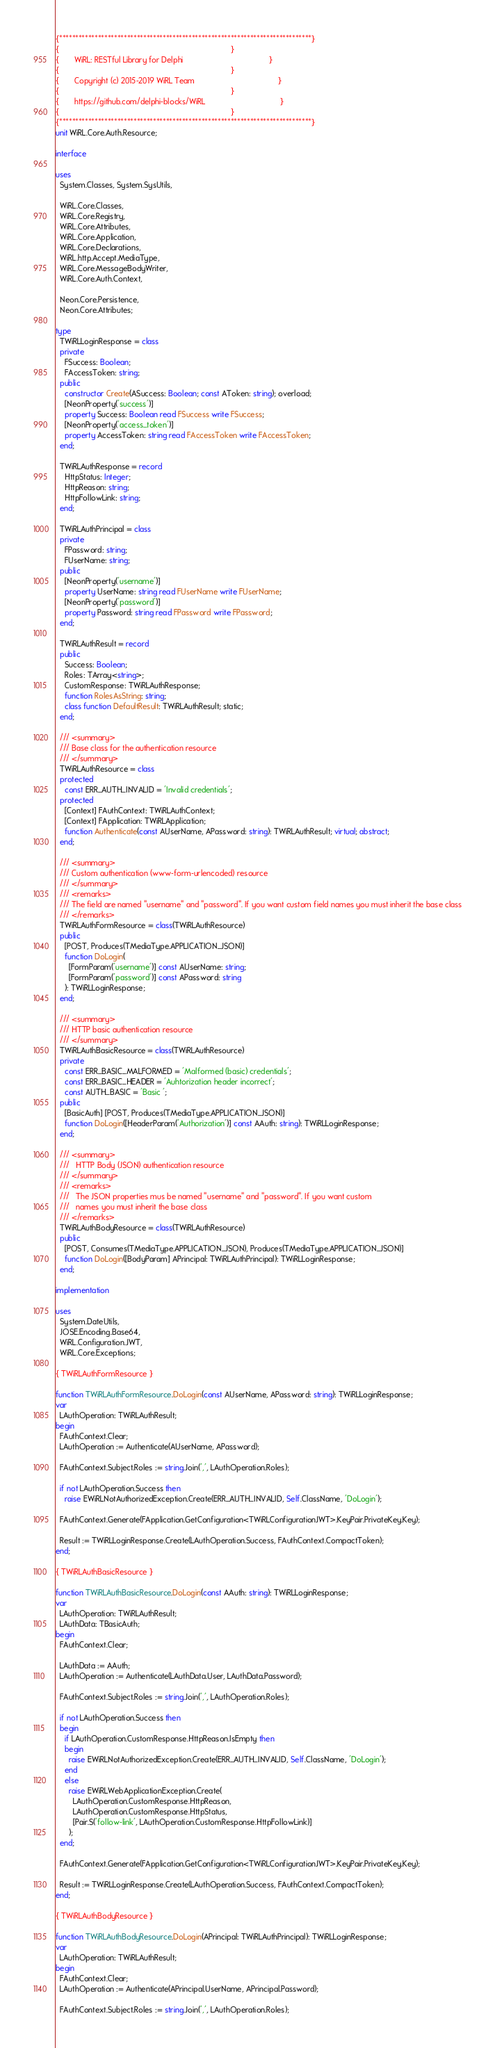<code> <loc_0><loc_0><loc_500><loc_500><_Pascal_>{******************************************************************************}
{                                                                              }
{       WiRL: RESTful Library for Delphi                                       }
{                                                                              }
{       Copyright (c) 2015-2019 WiRL Team                                      }
{                                                                              }
{       https://github.com/delphi-blocks/WiRL                                  }
{                                                                              }
{******************************************************************************}
unit WiRL.Core.Auth.Resource;

interface

uses
  System.Classes, System.SysUtils,

  WiRL.Core.Classes,
  WiRL.Core.Registry,
  WiRL.Core.Attributes,
  WiRL.Core.Application,
  WiRL.Core.Declarations,
  WiRL.http.Accept.MediaType,
  WiRL.Core.MessageBodyWriter,
  WiRL.Core.Auth.Context,

  Neon.Core.Persistence,
  Neon.Core.Attributes;

type
  TWiRLLoginResponse = class
  private
    FSuccess: Boolean;
    FAccessToken: string;
  public
    constructor Create(ASuccess: Boolean; const AToken: string); overload;
    [NeonProperty('success')]
    property Success: Boolean read FSuccess write FSuccess;
    [NeonProperty('access_token')]
    property AccessToken: string read FAccessToken write FAccessToken;
  end;

  TWiRLAuthResponse = record
    HttpStatus: Integer;
    HttpReason: string;
    HttpFollowLink: string;
  end;

  TWiRLAuthPrincipal = class
  private
    FPassword: string;
    FUserName: string;
  public
    [NeonProperty('username')]
    property UserName: string read FUserName write FUserName;
    [NeonProperty('password')]
    property Password: string read FPassword write FPassword;
  end;

  TWiRLAuthResult = record
  public
    Success: Boolean;
    Roles: TArray<string>;
    CustomResponse: TWiRLAuthResponse;
    function RolesAsString: string;
    class function DefaultResult: TWiRLAuthResult; static;
  end;

  /// <summary>
  /// Base class for the authentication resource
  /// </summary>
  TWiRLAuthResource = class
  protected
    const ERR_AUTH_INVALID = 'Invalid credentials';
  protected
    [Context] FAuthContext: TWiRLAuthContext;
    [Context] FApplication: TWiRLApplication;
    function Authenticate(const AUserName, APassword: string): TWiRLAuthResult; virtual; abstract;
  end;

  /// <summary>
  /// Custom authentication (www-form-urlencoded) resource
  /// </summary>
  /// <remarks>
  /// The field are named "username" and "password". If you want custom field names you must inherit the base class
  /// </remarks>
  TWiRLAuthFormResource = class(TWiRLAuthResource)
  public
    [POST, Produces(TMediaType.APPLICATION_JSON)]
    function DoLogin(
      [FormParam('username')] const AUserName: string;
      [FormParam('password')] const APassword: string
    ): TWiRLLoginResponse;
  end;

  /// <summary>
  /// HTTP basic authentication resource
  /// </summary>
  TWiRLAuthBasicResource = class(TWiRLAuthResource)
  private
    const ERR_BASIC_MALFORMED = 'Malformed (basic) credentials';
    const ERR_BASIC_HEADER = 'Auhtorization header incorrect';
    const AUTH_BASIC = 'Basic ';
  public
    [BasicAuth] [POST, Produces(TMediaType.APPLICATION_JSON)]
    function DoLogin([HeaderParam('Authorization')] const AAuth: string): TWiRLLoginResponse;
  end;

  /// <summary>
  ///   HTTP Body (JSON) authentication resource
  /// </summary>
  /// <remarks>
  ///   The JSON properties mus be named "username" and "password". If you want custom
  ///   names you must inherit the base class
  /// </remarks>
  TWiRLAuthBodyResource = class(TWiRLAuthResource)
  public
    [POST, Consumes(TMediaType.APPLICATION_JSON), Produces(TMediaType.APPLICATION_JSON)]
    function DoLogin([BodyParam] APrincipal: TWiRLAuthPrincipal): TWiRLLoginResponse;
  end;

implementation

uses
  System.DateUtils,
  JOSE.Encoding.Base64,
  WiRL.Configuration.JWT,
  WiRL.Core.Exceptions;

{ TWiRLAuthFormResource }

function TWiRLAuthFormResource.DoLogin(const AUserName, APassword: string): TWiRLLoginResponse;
var
  LAuthOperation: TWiRLAuthResult;
begin
  FAuthContext.Clear;
  LAuthOperation := Authenticate(AUserName, APassword);

  FAuthContext.Subject.Roles := string.Join(',', LAuthOperation.Roles);

  if not LAuthOperation.Success then
    raise EWiRLNotAuthorizedException.Create(ERR_AUTH_INVALID, Self.ClassName, 'DoLogin');

  FAuthContext.Generate(FApplication.GetConfiguration<TWiRLConfigurationJWT>.KeyPair.PrivateKey.Key);

  Result := TWiRLLoginResponse.Create(LAuthOperation.Success, FAuthContext.CompactToken);
end;

{ TWiRLAuthBasicResource }

function TWiRLAuthBasicResource.DoLogin(const AAuth: string): TWiRLLoginResponse;
var
  LAuthOperation: TWiRLAuthResult;
  LAuthData: TBasicAuth;
begin
  FAuthContext.Clear;

  LAuthData := AAuth;
  LAuthOperation := Authenticate(LAuthData.User, LAuthData.Password);

  FAuthContext.Subject.Roles := string.Join(',', LAuthOperation.Roles);

  if not LAuthOperation.Success then
  begin
    if LAuthOperation.CustomResponse.HttpReason.IsEmpty then
    begin
      raise EWiRLNotAuthorizedException.Create(ERR_AUTH_INVALID, Self.ClassName, 'DoLogin');
    end
    else
      raise EWiRLWebApplicationException.Create(
        LAuthOperation.CustomResponse.HttpReason,
        LAuthOperation.CustomResponse.HttpStatus,
        [Pair.S('follow-link', LAuthOperation.CustomResponse.HttpFollowLink)]
      );
  end;

  FAuthContext.Generate(FApplication.GetConfiguration<TWiRLConfigurationJWT>.KeyPair.PrivateKey.Key);

  Result := TWiRLLoginResponse.Create(LAuthOperation.Success, FAuthContext.CompactToken);
end;

{ TWiRLAuthBodyResource }

function TWiRLAuthBodyResource.DoLogin(APrincipal: TWiRLAuthPrincipal): TWiRLLoginResponse;
var
  LAuthOperation: TWiRLAuthResult;
begin
  FAuthContext.Clear;
  LAuthOperation := Authenticate(APrincipal.UserName, APrincipal.Password);

  FAuthContext.Subject.Roles := string.Join(',', LAuthOperation.Roles);
</code> 